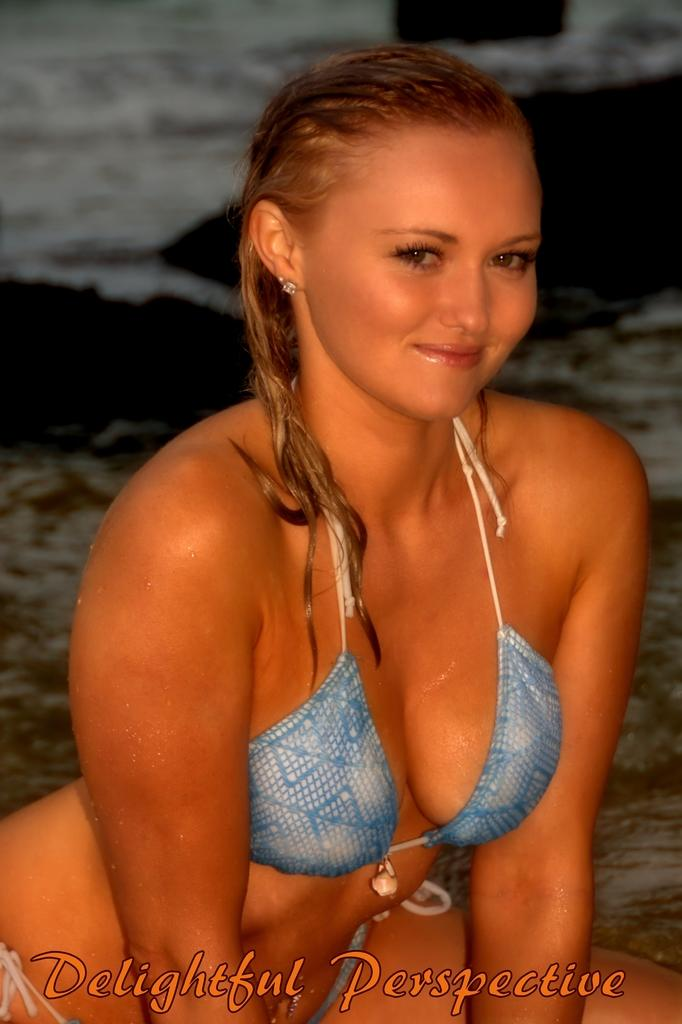Who is present in the image? There is a woman in the image. What is the woman's facial expression? The woman is smiling. What can be seen in the background of the image? There is water visible in the background of the image. What is written at the bottom of the image? There is text at the bottom of the image. What type of development is taking place in the image? There is no development project or construction site present in the image; it features a woman smiling with water visible in the background. What kind of breakfast is the woman eating in the image? There is no food or breakfast visible in the image; it only shows a woman smiling with text at the bottom and water in the background. 